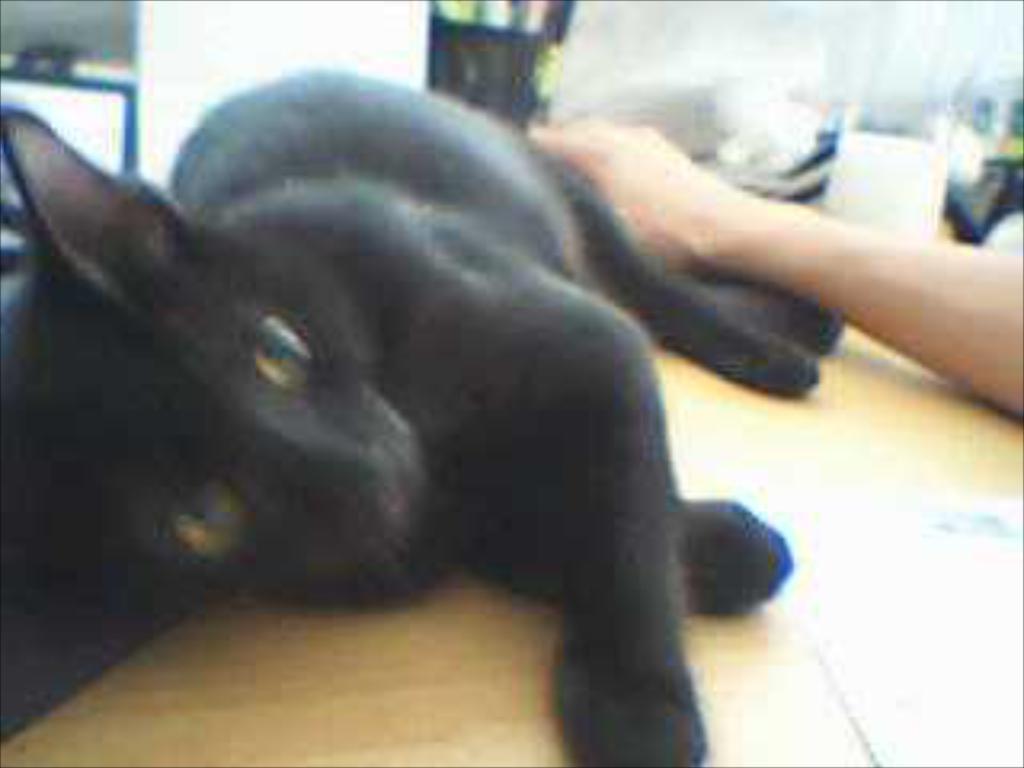Could you give a brief overview of what you see in this image? In the picture I can see a black color cat on the wooden table and there is a hand of a person on the right side. 